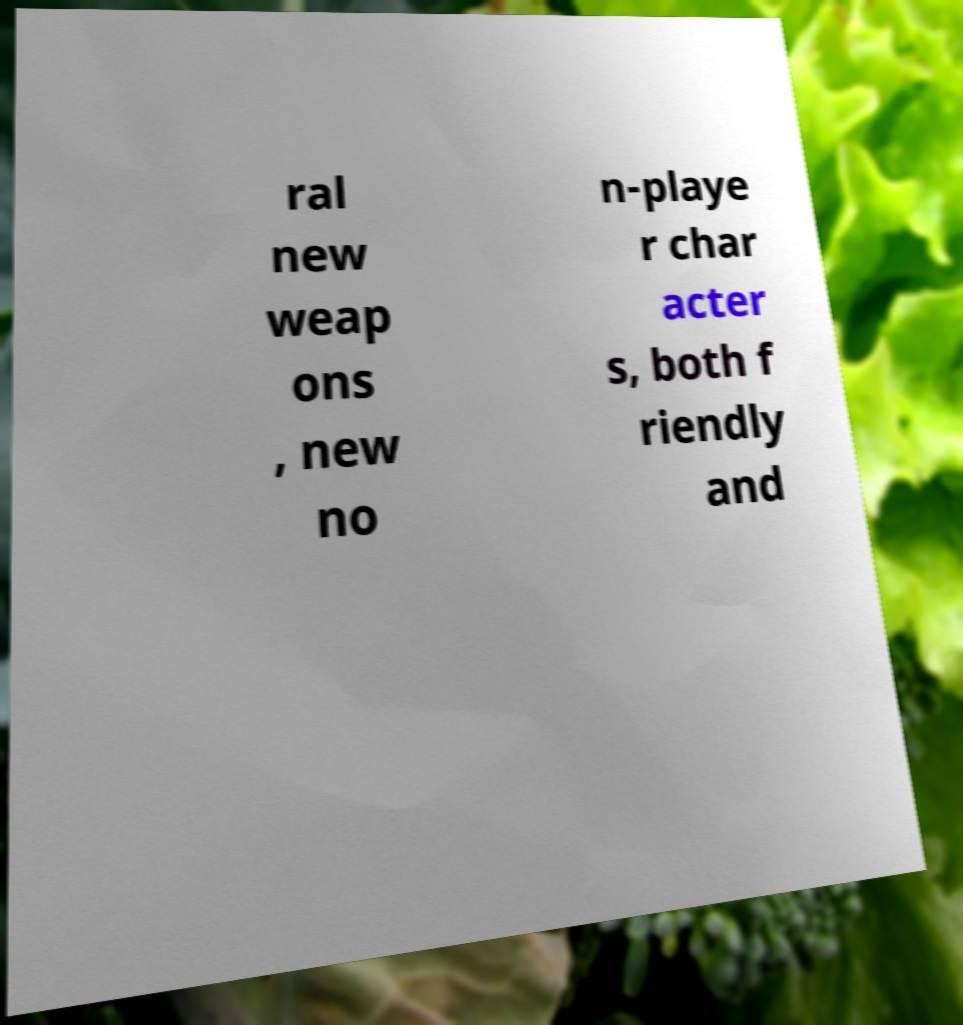What messages or text are displayed in this image? I need them in a readable, typed format. ral new weap ons , new no n-playe r char acter s, both f riendly and 